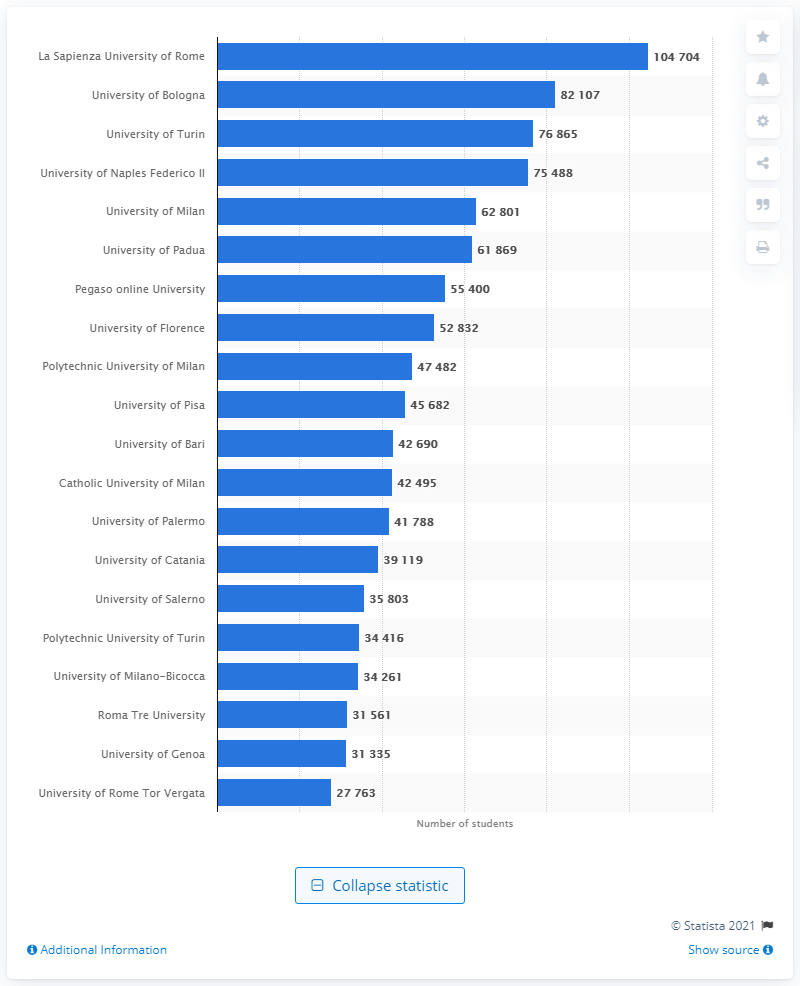Highlight a few significant elements in this photo. La Sapienza University of Rome is the largest Italian university. In the 2019/2020 academic year, a total of 104,704 students were enrolled at La Sapienza University of Rome. The University of Bologna is widely considered to be the best Italian university. 